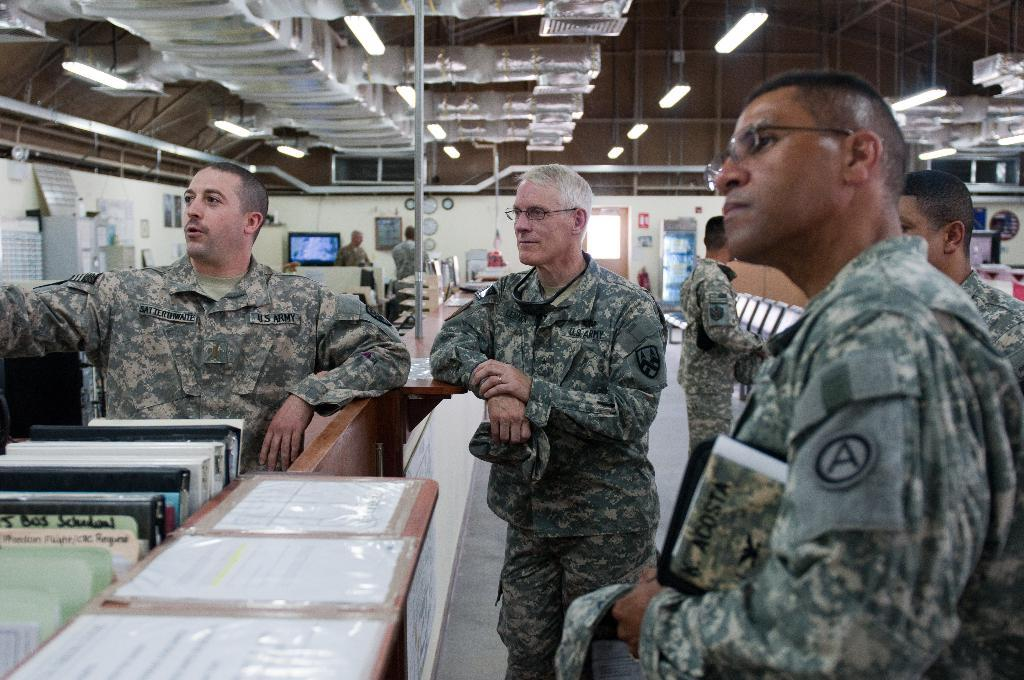What type of people can be seen in the image? There are soldiers standing in the image. What else can be seen in the image besides the soldiers? There are books, walls, a television mounted on a wall, a shed, and lights visible in the image. Where is the television located in the image? The television is mounted on a wall in the image. What is visible at the top of the image? There is a shed and lights visible at the top of the image. Can you see a shelf filled with books near the lake in the image? There is no shelf or lake present in the image. Is there a ball being thrown by the soldiers in the image? There is no ball visible in the image; the soldiers are not engaged in any activity involving a ball. 